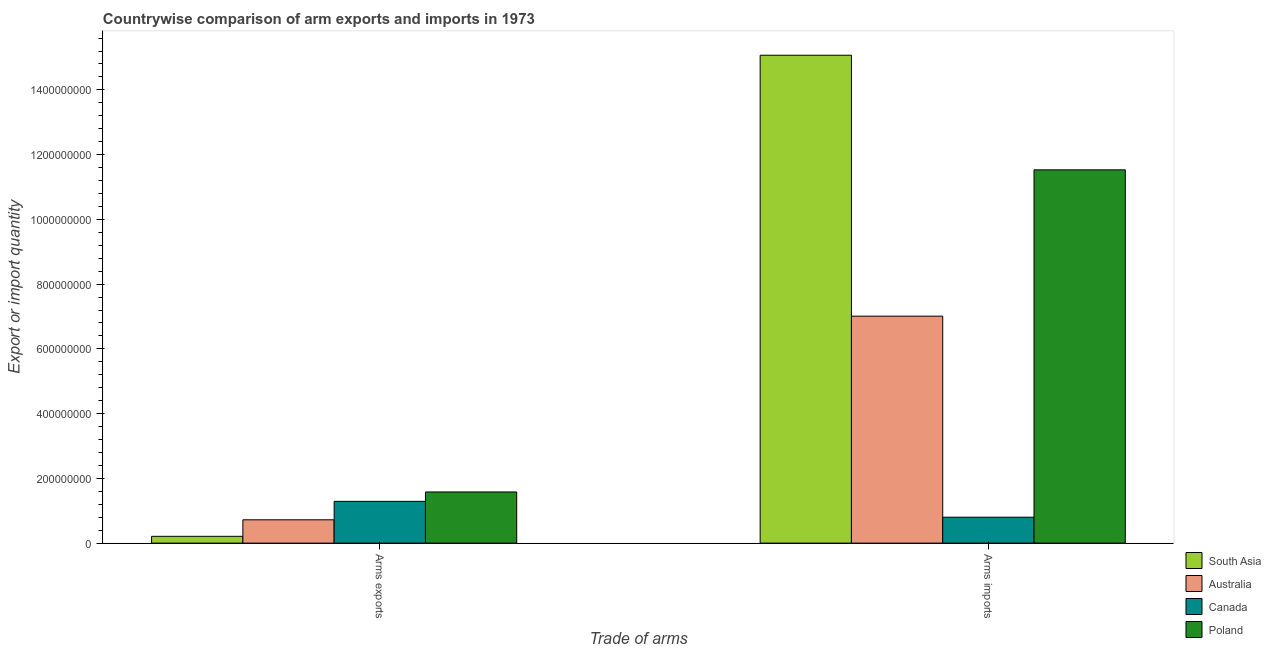How many different coloured bars are there?
Your response must be concise. 4. How many groups of bars are there?
Your response must be concise. 2. Are the number of bars on each tick of the X-axis equal?
Provide a succinct answer. Yes. What is the label of the 2nd group of bars from the left?
Offer a terse response. Arms imports. What is the arms exports in Canada?
Provide a succinct answer. 1.29e+08. Across all countries, what is the maximum arms imports?
Ensure brevity in your answer.  1.51e+09. Across all countries, what is the minimum arms imports?
Provide a short and direct response. 8.00e+07. In which country was the arms exports maximum?
Ensure brevity in your answer.  Poland. In which country was the arms imports minimum?
Give a very brief answer. Canada. What is the total arms imports in the graph?
Keep it short and to the point. 3.44e+09. What is the difference between the arms imports in Canada and that in Poland?
Provide a short and direct response. -1.07e+09. What is the difference between the arms imports in Australia and the arms exports in South Asia?
Keep it short and to the point. 6.80e+08. What is the average arms exports per country?
Provide a short and direct response. 9.50e+07. What is the difference between the arms imports and arms exports in Poland?
Provide a succinct answer. 9.95e+08. In how many countries, is the arms exports greater than 760000000 ?
Keep it short and to the point. 0. What is the ratio of the arms imports in South Asia to that in Poland?
Your answer should be compact. 1.31. What does the 1st bar from the left in Arms imports represents?
Ensure brevity in your answer.  South Asia. How many countries are there in the graph?
Your answer should be compact. 4. Does the graph contain any zero values?
Your answer should be very brief. No. Does the graph contain grids?
Your answer should be compact. No. Where does the legend appear in the graph?
Ensure brevity in your answer.  Bottom right. How are the legend labels stacked?
Give a very brief answer. Vertical. What is the title of the graph?
Provide a succinct answer. Countrywise comparison of arm exports and imports in 1973. What is the label or title of the X-axis?
Give a very brief answer. Trade of arms. What is the label or title of the Y-axis?
Keep it short and to the point. Export or import quantity. What is the Export or import quantity of South Asia in Arms exports?
Your response must be concise. 2.10e+07. What is the Export or import quantity of Australia in Arms exports?
Provide a succinct answer. 7.20e+07. What is the Export or import quantity of Canada in Arms exports?
Provide a succinct answer. 1.29e+08. What is the Export or import quantity of Poland in Arms exports?
Your answer should be compact. 1.58e+08. What is the Export or import quantity in South Asia in Arms imports?
Your response must be concise. 1.51e+09. What is the Export or import quantity in Australia in Arms imports?
Provide a succinct answer. 7.01e+08. What is the Export or import quantity of Canada in Arms imports?
Offer a very short reply. 8.00e+07. What is the Export or import quantity of Poland in Arms imports?
Offer a terse response. 1.15e+09. Across all Trade of arms, what is the maximum Export or import quantity of South Asia?
Ensure brevity in your answer.  1.51e+09. Across all Trade of arms, what is the maximum Export or import quantity of Australia?
Offer a terse response. 7.01e+08. Across all Trade of arms, what is the maximum Export or import quantity in Canada?
Your response must be concise. 1.29e+08. Across all Trade of arms, what is the maximum Export or import quantity of Poland?
Give a very brief answer. 1.15e+09. Across all Trade of arms, what is the minimum Export or import quantity in South Asia?
Keep it short and to the point. 2.10e+07. Across all Trade of arms, what is the minimum Export or import quantity of Australia?
Your answer should be compact. 7.20e+07. Across all Trade of arms, what is the minimum Export or import quantity of Canada?
Your answer should be very brief. 8.00e+07. Across all Trade of arms, what is the minimum Export or import quantity in Poland?
Offer a terse response. 1.58e+08. What is the total Export or import quantity of South Asia in the graph?
Provide a short and direct response. 1.53e+09. What is the total Export or import quantity of Australia in the graph?
Your response must be concise. 7.73e+08. What is the total Export or import quantity in Canada in the graph?
Keep it short and to the point. 2.09e+08. What is the total Export or import quantity in Poland in the graph?
Ensure brevity in your answer.  1.31e+09. What is the difference between the Export or import quantity of South Asia in Arms exports and that in Arms imports?
Keep it short and to the point. -1.49e+09. What is the difference between the Export or import quantity of Australia in Arms exports and that in Arms imports?
Offer a very short reply. -6.29e+08. What is the difference between the Export or import quantity of Canada in Arms exports and that in Arms imports?
Ensure brevity in your answer.  4.90e+07. What is the difference between the Export or import quantity of Poland in Arms exports and that in Arms imports?
Provide a short and direct response. -9.95e+08. What is the difference between the Export or import quantity in South Asia in Arms exports and the Export or import quantity in Australia in Arms imports?
Make the answer very short. -6.80e+08. What is the difference between the Export or import quantity in South Asia in Arms exports and the Export or import quantity in Canada in Arms imports?
Keep it short and to the point. -5.90e+07. What is the difference between the Export or import quantity of South Asia in Arms exports and the Export or import quantity of Poland in Arms imports?
Offer a very short reply. -1.13e+09. What is the difference between the Export or import quantity of Australia in Arms exports and the Export or import quantity of Canada in Arms imports?
Provide a succinct answer. -8.00e+06. What is the difference between the Export or import quantity of Australia in Arms exports and the Export or import quantity of Poland in Arms imports?
Keep it short and to the point. -1.08e+09. What is the difference between the Export or import quantity of Canada in Arms exports and the Export or import quantity of Poland in Arms imports?
Provide a succinct answer. -1.02e+09. What is the average Export or import quantity of South Asia per Trade of arms?
Provide a short and direct response. 7.64e+08. What is the average Export or import quantity of Australia per Trade of arms?
Keep it short and to the point. 3.86e+08. What is the average Export or import quantity in Canada per Trade of arms?
Offer a terse response. 1.04e+08. What is the average Export or import quantity in Poland per Trade of arms?
Ensure brevity in your answer.  6.56e+08. What is the difference between the Export or import quantity of South Asia and Export or import quantity of Australia in Arms exports?
Provide a succinct answer. -5.10e+07. What is the difference between the Export or import quantity in South Asia and Export or import quantity in Canada in Arms exports?
Make the answer very short. -1.08e+08. What is the difference between the Export or import quantity of South Asia and Export or import quantity of Poland in Arms exports?
Your answer should be compact. -1.37e+08. What is the difference between the Export or import quantity of Australia and Export or import quantity of Canada in Arms exports?
Your answer should be very brief. -5.70e+07. What is the difference between the Export or import quantity of Australia and Export or import quantity of Poland in Arms exports?
Offer a terse response. -8.60e+07. What is the difference between the Export or import quantity of Canada and Export or import quantity of Poland in Arms exports?
Offer a very short reply. -2.90e+07. What is the difference between the Export or import quantity in South Asia and Export or import quantity in Australia in Arms imports?
Provide a succinct answer. 8.06e+08. What is the difference between the Export or import quantity of South Asia and Export or import quantity of Canada in Arms imports?
Provide a short and direct response. 1.43e+09. What is the difference between the Export or import quantity of South Asia and Export or import quantity of Poland in Arms imports?
Your answer should be very brief. 3.54e+08. What is the difference between the Export or import quantity of Australia and Export or import quantity of Canada in Arms imports?
Your response must be concise. 6.21e+08. What is the difference between the Export or import quantity in Australia and Export or import quantity in Poland in Arms imports?
Make the answer very short. -4.52e+08. What is the difference between the Export or import quantity in Canada and Export or import quantity in Poland in Arms imports?
Make the answer very short. -1.07e+09. What is the ratio of the Export or import quantity in South Asia in Arms exports to that in Arms imports?
Your response must be concise. 0.01. What is the ratio of the Export or import quantity of Australia in Arms exports to that in Arms imports?
Ensure brevity in your answer.  0.1. What is the ratio of the Export or import quantity of Canada in Arms exports to that in Arms imports?
Your answer should be compact. 1.61. What is the ratio of the Export or import quantity in Poland in Arms exports to that in Arms imports?
Keep it short and to the point. 0.14. What is the difference between the highest and the second highest Export or import quantity in South Asia?
Provide a succinct answer. 1.49e+09. What is the difference between the highest and the second highest Export or import quantity in Australia?
Your answer should be very brief. 6.29e+08. What is the difference between the highest and the second highest Export or import quantity of Canada?
Make the answer very short. 4.90e+07. What is the difference between the highest and the second highest Export or import quantity of Poland?
Your response must be concise. 9.95e+08. What is the difference between the highest and the lowest Export or import quantity of South Asia?
Your answer should be very brief. 1.49e+09. What is the difference between the highest and the lowest Export or import quantity in Australia?
Provide a succinct answer. 6.29e+08. What is the difference between the highest and the lowest Export or import quantity in Canada?
Offer a very short reply. 4.90e+07. What is the difference between the highest and the lowest Export or import quantity in Poland?
Provide a succinct answer. 9.95e+08. 